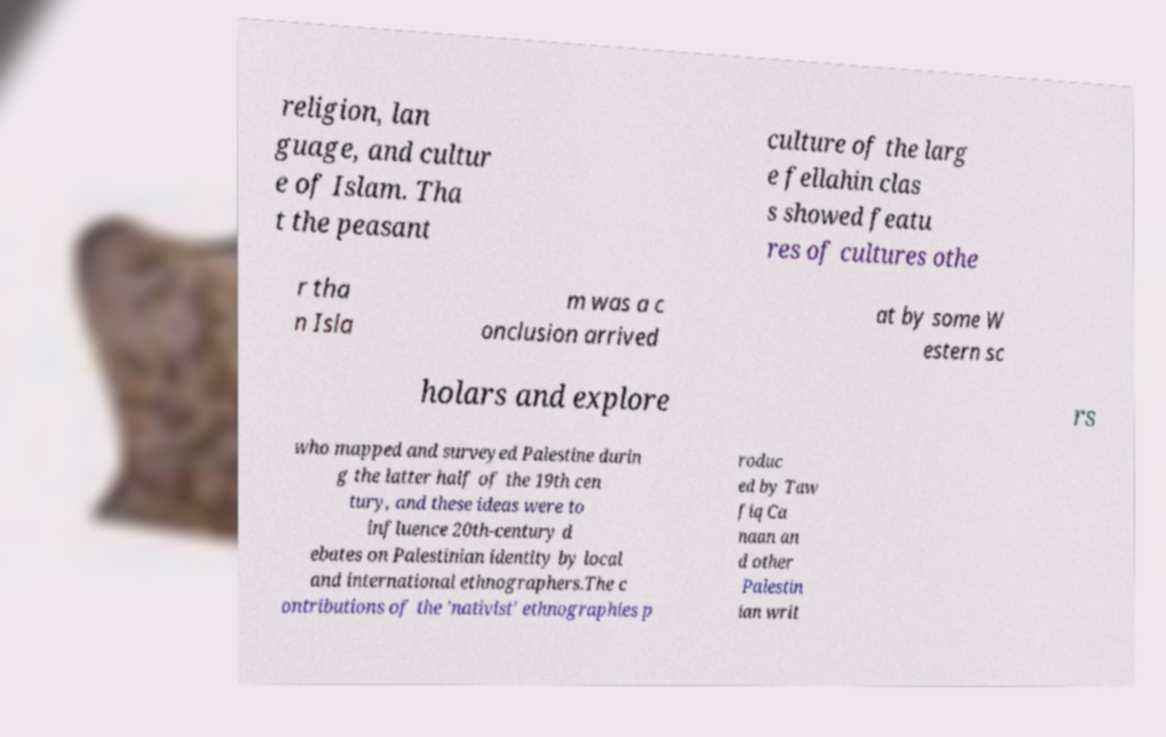Can you accurately transcribe the text from the provided image for me? religion, lan guage, and cultur e of Islam. Tha t the peasant culture of the larg e fellahin clas s showed featu res of cultures othe r tha n Isla m was a c onclusion arrived at by some W estern sc holars and explore rs who mapped and surveyed Palestine durin g the latter half of the 19th cen tury, and these ideas were to influence 20th-century d ebates on Palestinian identity by local and international ethnographers.The c ontributions of the 'nativist' ethnographies p roduc ed by Taw fiq Ca naan an d other Palestin ian writ 